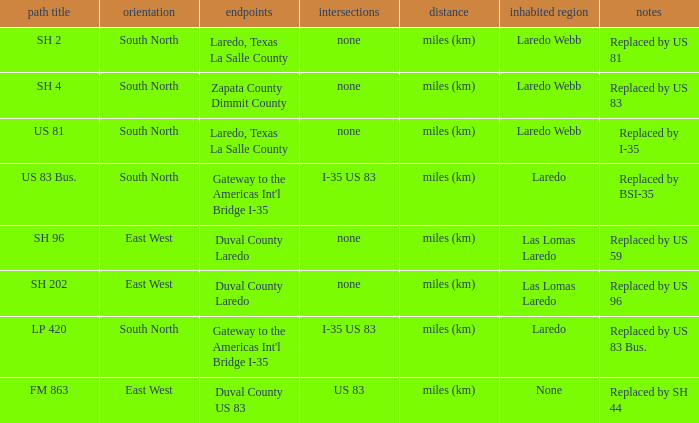Which population areas have "replaced by us 83" listed in their remarks section? Laredo Webb. 